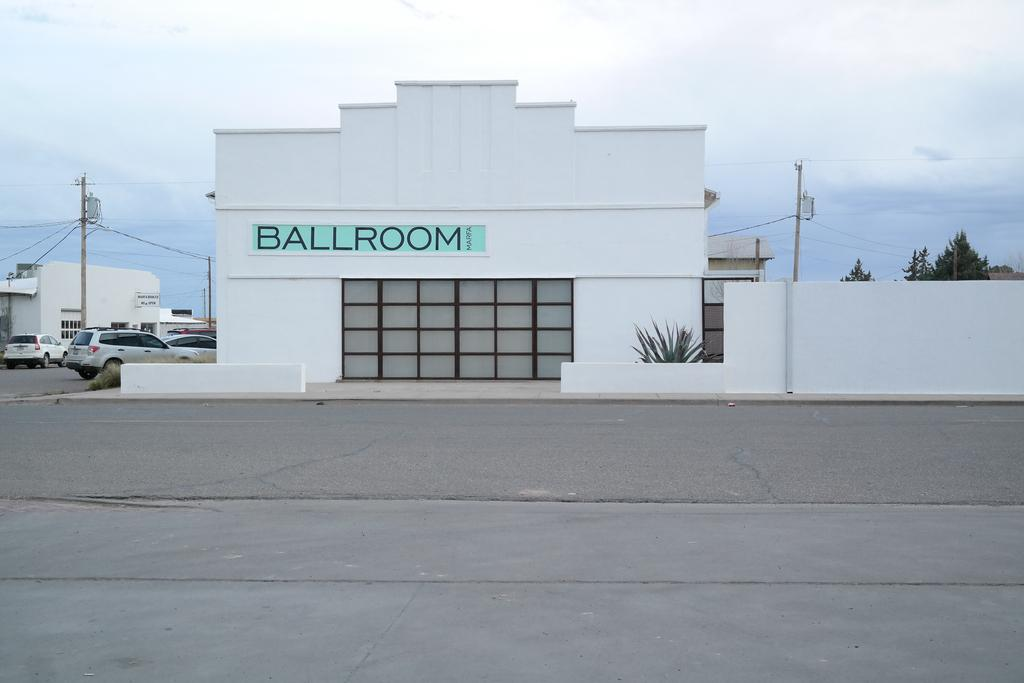What is located in the center of the image? There are buildings in the center of the image. What can be seen on the left side of the image? There are cars on the road on the left side of the image. What objects are present in the image that support structures or utilities? There are poles in the image. What type of vegetation is visible in the image? There are trees and a plant in the image. What is visible at the top of the image? The sky is visible at the top of the image, along with wires. Where are the cattle grazing in the image? There are no cattle present in the image. What type of fang can be seen in the image? There is no fang present in the image. 